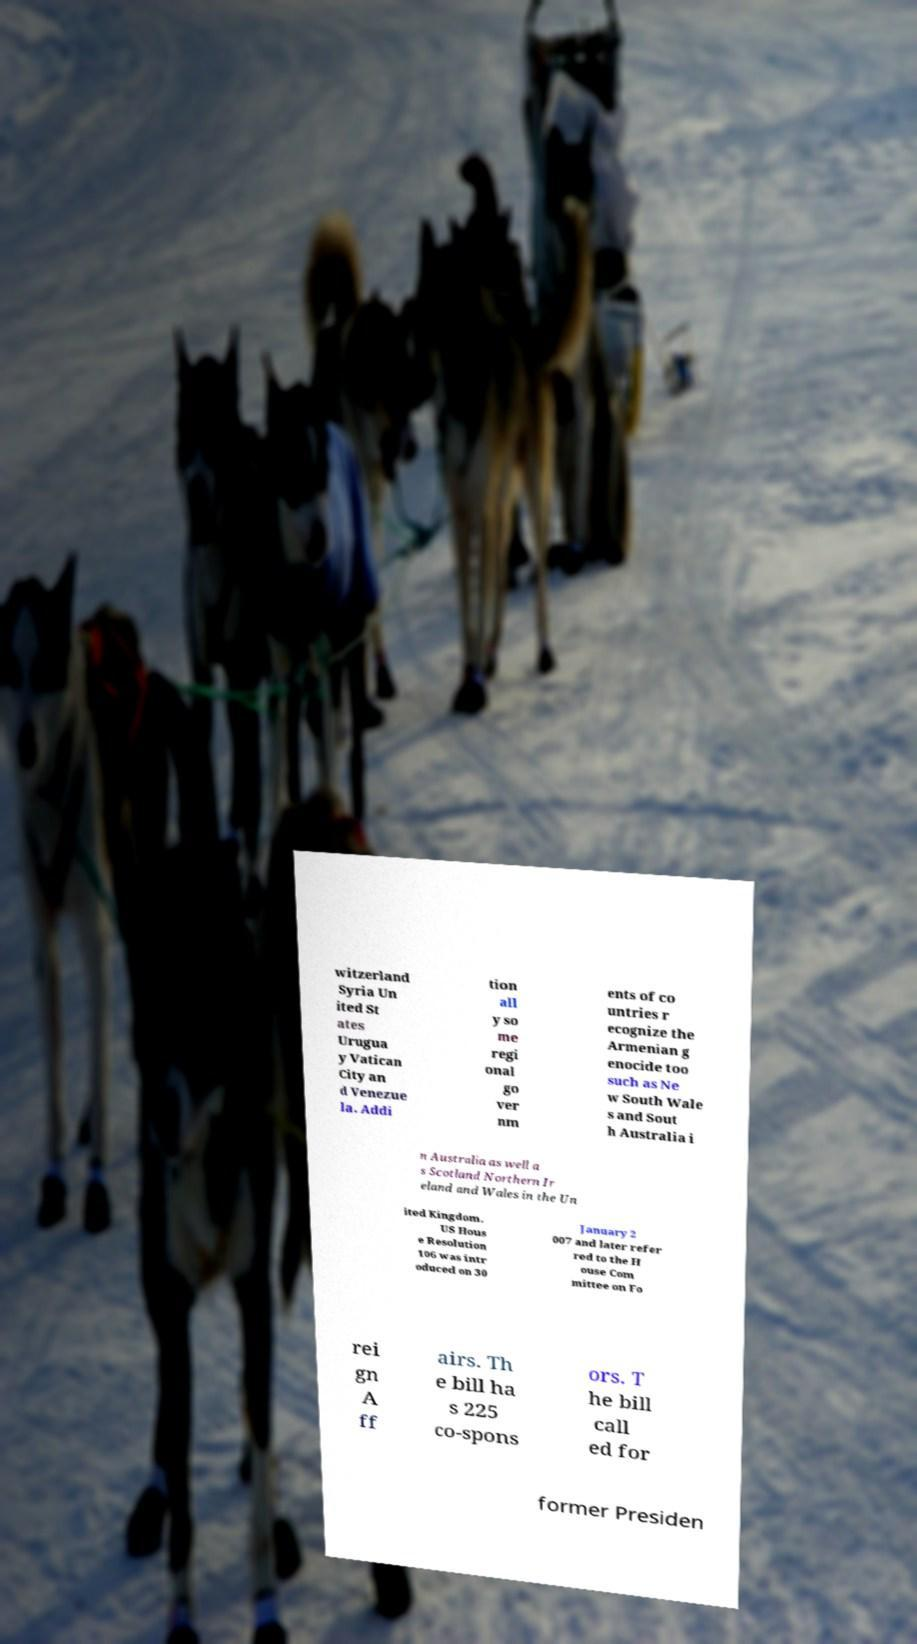Can you accurately transcribe the text from the provided image for me? witzerland Syria Un ited St ates Urugua y Vatican City an d Venezue la. Addi tion all y so me regi onal go ver nm ents of co untries r ecognize the Armenian g enocide too such as Ne w South Wale s and Sout h Australia i n Australia as well a s Scotland Northern Ir eland and Wales in the Un ited Kingdom. US Hous e Resolution 106 was intr oduced on 30 January 2 007 and later refer red to the H ouse Com mittee on Fo rei gn A ff airs. Th e bill ha s 225 co-spons ors. T he bill call ed for former Presiden 